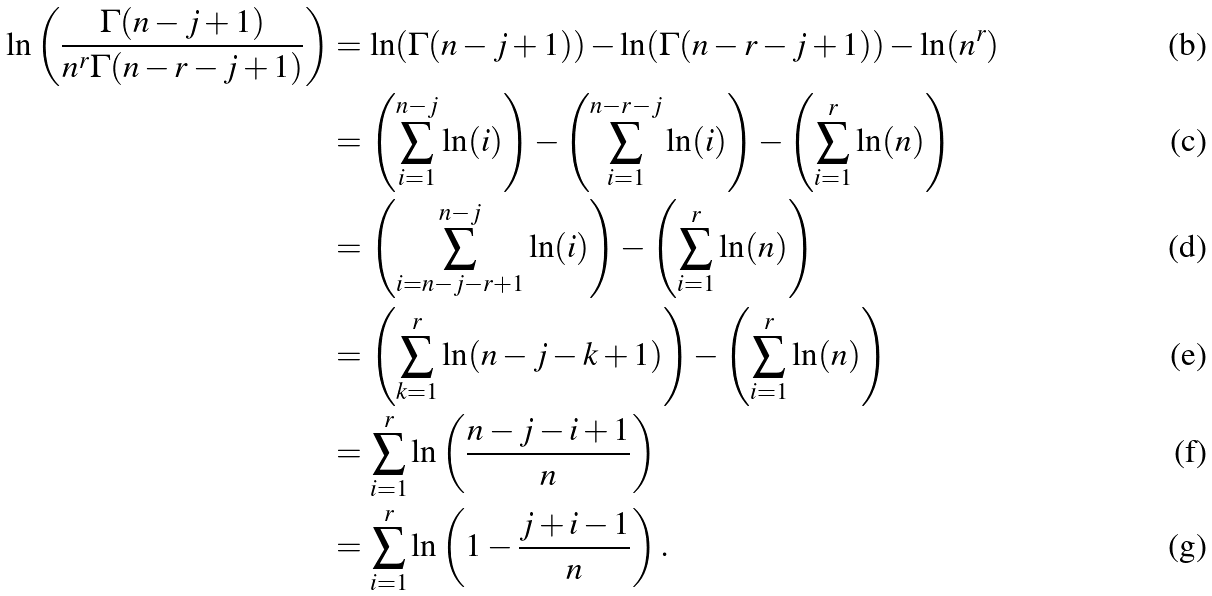<formula> <loc_0><loc_0><loc_500><loc_500>\ln \left ( \frac { \Gamma ( n - j + 1 ) } { n ^ { r } \Gamma ( n - r - j + 1 ) } \right ) & = \ln ( \Gamma ( n - j + 1 ) ) - \ln ( \Gamma ( n - r - j + 1 ) ) - \ln ( n ^ { r } ) \\ & = \left ( \sum _ { i = 1 } ^ { n - j } \ln ( i ) \right ) - \left ( \sum _ { i = 1 } ^ { n - r - j } \ln ( i ) \right ) - \left ( \sum _ { i = 1 } ^ { r } \ln ( n ) \right ) \\ & = \left ( \sum _ { i = n - j - r + 1 } ^ { n - j } \ln ( i ) \right ) - \left ( \sum _ { i = 1 } ^ { r } \ln ( n ) \right ) \\ & = \left ( \sum _ { k = 1 } ^ { r } \ln ( n - j - k + 1 ) \right ) - \left ( \sum _ { i = 1 } ^ { r } \ln ( n ) \right ) \\ & = \sum _ { i = 1 } ^ { r } \ln \left ( \frac { n - j - i + 1 } { n } \right ) \\ & = \sum _ { i = 1 } ^ { r } \ln \left ( 1 - \frac { j + i - 1 } { n } \right ) .</formula> 